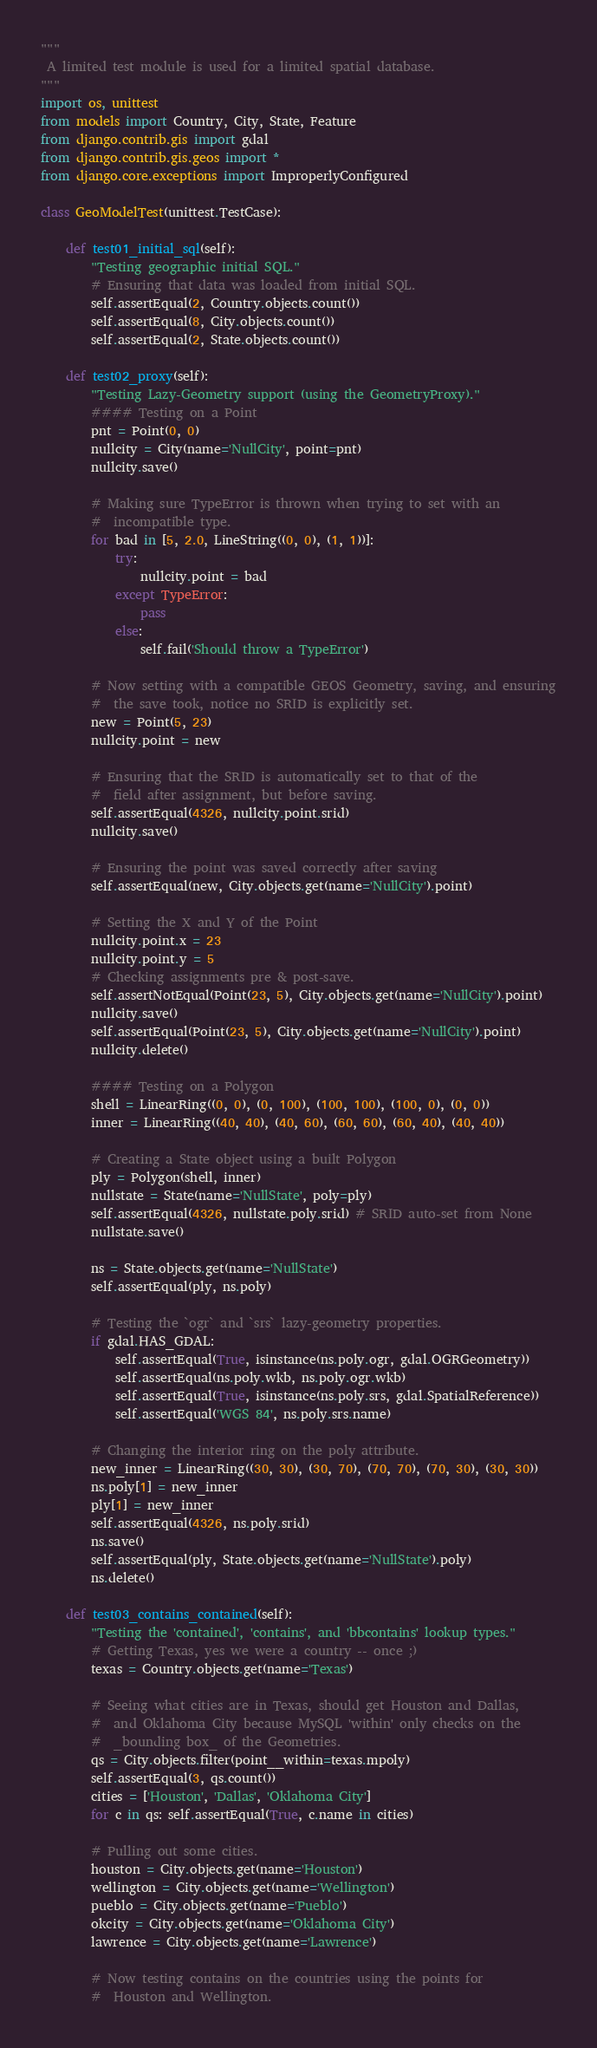Convert code to text. <code><loc_0><loc_0><loc_500><loc_500><_Python_>"""
 A limited test module is used for a limited spatial database.
"""
import os, unittest
from models import Country, City, State, Feature
from django.contrib.gis import gdal
from django.contrib.gis.geos import *
from django.core.exceptions import ImproperlyConfigured

class GeoModelTest(unittest.TestCase):

    def test01_initial_sql(self):
        "Testing geographic initial SQL."
        # Ensuring that data was loaded from initial SQL.
        self.assertEqual(2, Country.objects.count())
        self.assertEqual(8, City.objects.count())
        self.assertEqual(2, State.objects.count())

    def test02_proxy(self):
        "Testing Lazy-Geometry support (using the GeometryProxy)."
        #### Testing on a Point
        pnt = Point(0, 0)
        nullcity = City(name='NullCity', point=pnt)
        nullcity.save()

        # Making sure TypeError is thrown when trying to set with an
        #  incompatible type.
        for bad in [5, 2.0, LineString((0, 0), (1, 1))]:
            try:
                nullcity.point = bad
            except TypeError:
                pass
            else:
                self.fail('Should throw a TypeError')

        # Now setting with a compatible GEOS Geometry, saving, and ensuring
        #  the save took, notice no SRID is explicitly set.
        new = Point(5, 23)
        nullcity.point = new

        # Ensuring that the SRID is automatically set to that of the
        #  field after assignment, but before saving.
        self.assertEqual(4326, nullcity.point.srid)
        nullcity.save()

        # Ensuring the point was saved correctly after saving
        self.assertEqual(new, City.objects.get(name='NullCity').point)

        # Setting the X and Y of the Point
        nullcity.point.x = 23
        nullcity.point.y = 5
        # Checking assignments pre & post-save.
        self.assertNotEqual(Point(23, 5), City.objects.get(name='NullCity').point)
        nullcity.save()
        self.assertEqual(Point(23, 5), City.objects.get(name='NullCity').point)
        nullcity.delete()

        #### Testing on a Polygon
        shell = LinearRing((0, 0), (0, 100), (100, 100), (100, 0), (0, 0))
        inner = LinearRing((40, 40), (40, 60), (60, 60), (60, 40), (40, 40))

        # Creating a State object using a built Polygon
        ply = Polygon(shell, inner)
        nullstate = State(name='NullState', poly=ply)
        self.assertEqual(4326, nullstate.poly.srid) # SRID auto-set from None
        nullstate.save()

        ns = State.objects.get(name='NullState')
        self.assertEqual(ply, ns.poly)

        # Testing the `ogr` and `srs` lazy-geometry properties.
        if gdal.HAS_GDAL:
            self.assertEqual(True, isinstance(ns.poly.ogr, gdal.OGRGeometry))
            self.assertEqual(ns.poly.wkb, ns.poly.ogr.wkb)
            self.assertEqual(True, isinstance(ns.poly.srs, gdal.SpatialReference))
            self.assertEqual('WGS 84', ns.poly.srs.name)

        # Changing the interior ring on the poly attribute.
        new_inner = LinearRing((30, 30), (30, 70), (70, 70), (70, 30), (30, 30))
        ns.poly[1] = new_inner
        ply[1] = new_inner
        self.assertEqual(4326, ns.poly.srid)
        ns.save()
        self.assertEqual(ply, State.objects.get(name='NullState').poly)
        ns.delete()

    def test03_contains_contained(self):
        "Testing the 'contained', 'contains', and 'bbcontains' lookup types."
        # Getting Texas, yes we were a country -- once ;)
        texas = Country.objects.get(name='Texas')

        # Seeing what cities are in Texas, should get Houston and Dallas,
        #  and Oklahoma City because MySQL 'within' only checks on the
        #  _bounding box_ of the Geometries.
        qs = City.objects.filter(point__within=texas.mpoly)
        self.assertEqual(3, qs.count())
        cities = ['Houston', 'Dallas', 'Oklahoma City']
        for c in qs: self.assertEqual(True, c.name in cities)

        # Pulling out some cities.
        houston = City.objects.get(name='Houston')
        wellington = City.objects.get(name='Wellington')
        pueblo = City.objects.get(name='Pueblo')
        okcity = City.objects.get(name='Oklahoma City')
        lawrence = City.objects.get(name='Lawrence')

        # Now testing contains on the countries using the points for
        #  Houston and Wellington.</code> 